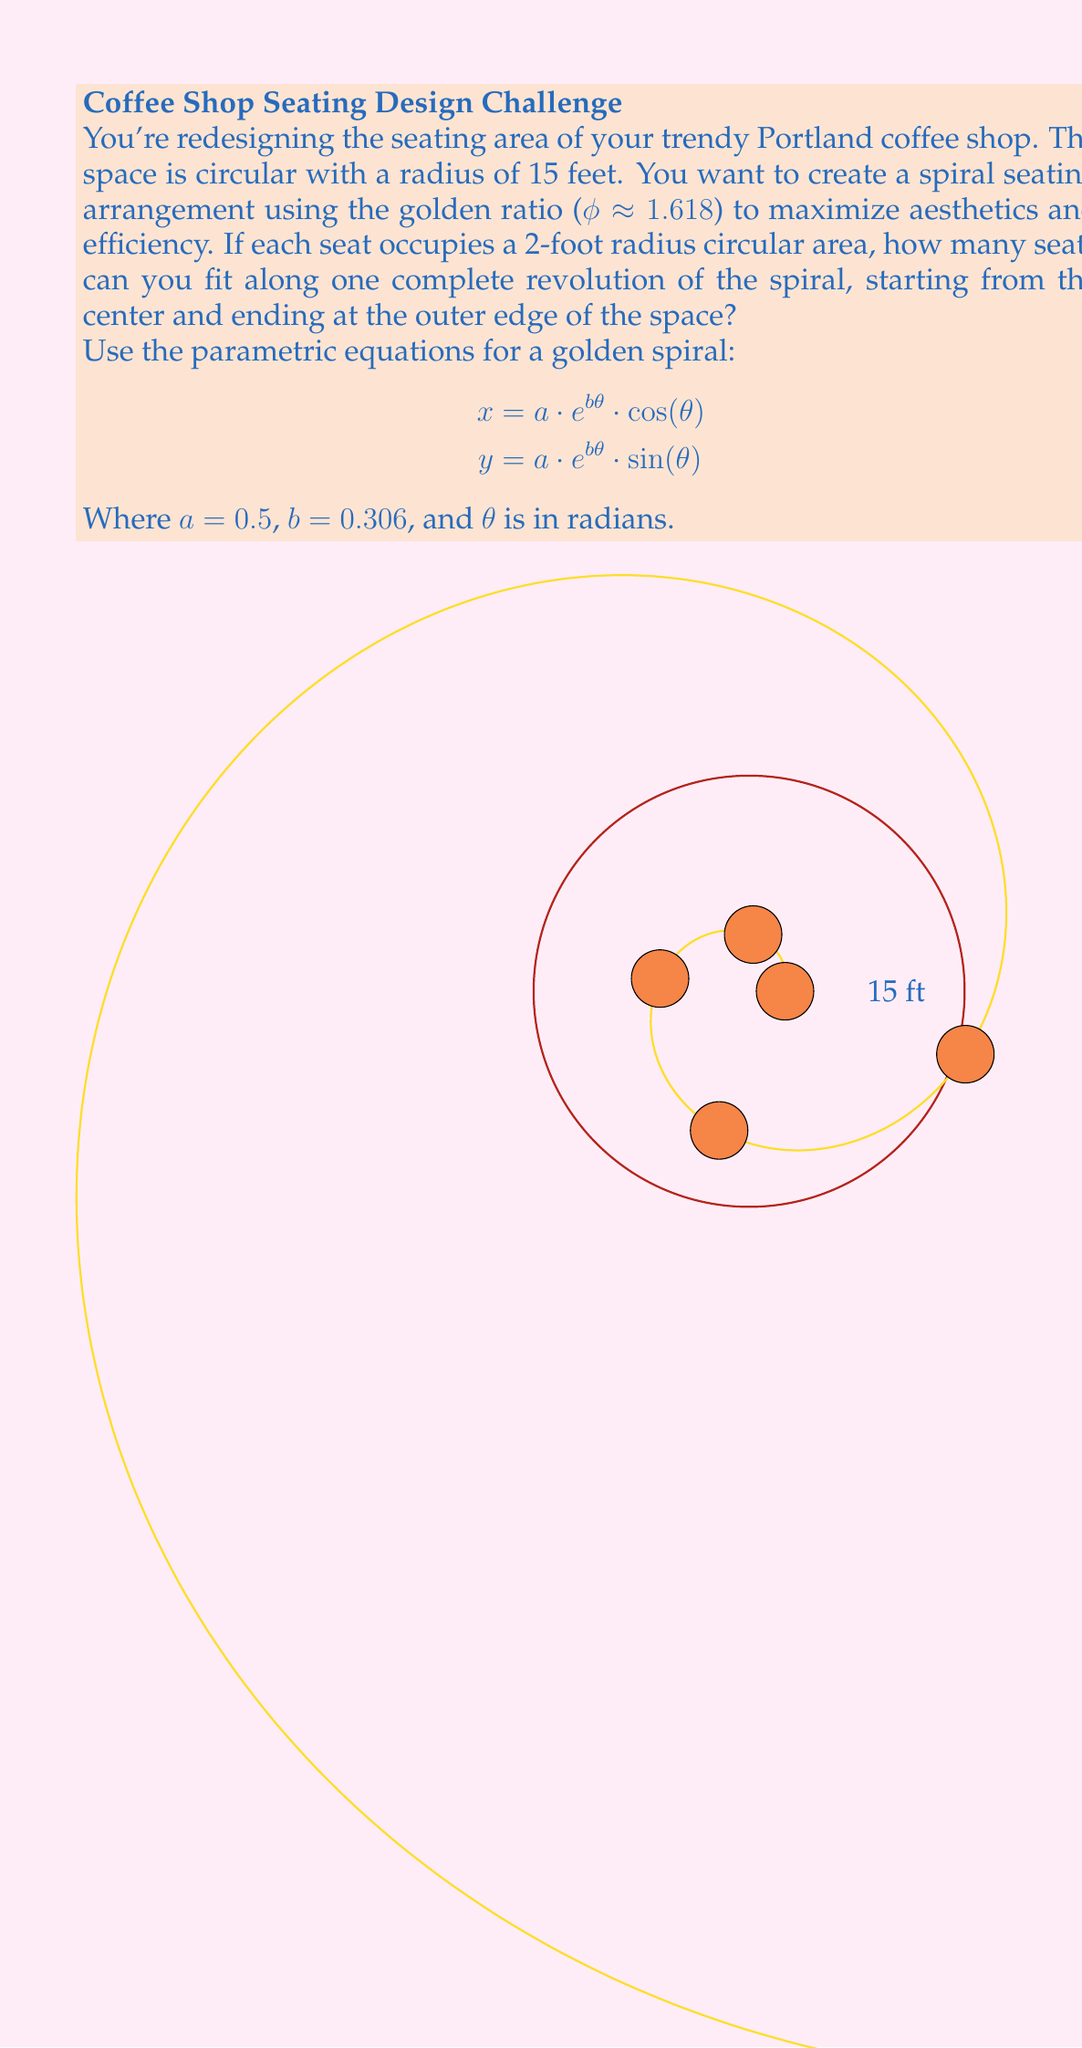Show me your answer to this math problem. Let's approach this step-by-step:

1) First, we need to find the angle θ that corresponds to the outer edge of the space. We can do this by setting the radius of the spiral equal to the radius of the space (15 feet):

   $$15 = 0.5 * e^{0.306 * θ}$$

2) Solving for θ:
   $$e^{0.306 * θ} = 30$$
   $$0.306 * θ = ln(30)$$
   $$θ = \frac{ln(30)}{0.306} ≈ 11.12 \text{ radians}$$

3) Now, we need to determine how much angle is needed between each seat. The distance between seats along the spiral should be at least 4 feet (twice the radius of each seat area).

4) We can use the arc length formula for a logarithmic spiral to calculate this:
   $$s = \frac{a}{b} * (e^{b * θ_2} - e^{b * θ_1})$$

   Where $s$ is the arc length, and $θ_2 - θ_1$ is the angle between two points.

5) Setting $s = 4$ and solving for $Δθ = θ_2 - θ_1$:
   $$4 = \frac{0.5}{0.306} * (e^{0.306 * Δθ} - 1)$$
   $$e^{0.306 * Δθ} = 1 + 4 * \frac{0.306}{0.5} = 3.47$$
   $$Δθ = \frac{ln(3.47)}{0.306} ≈ 4.08 \text{ radians}$$

6) The number of seats we can fit is the total angle divided by the angle between seats:
   $$\text{Number of seats} = \frac{11.12}{4.08} ≈ 2.73$$

7) Since we can't have a fractional number of seats, we round down to 2 seats.
Answer: 2 seats 